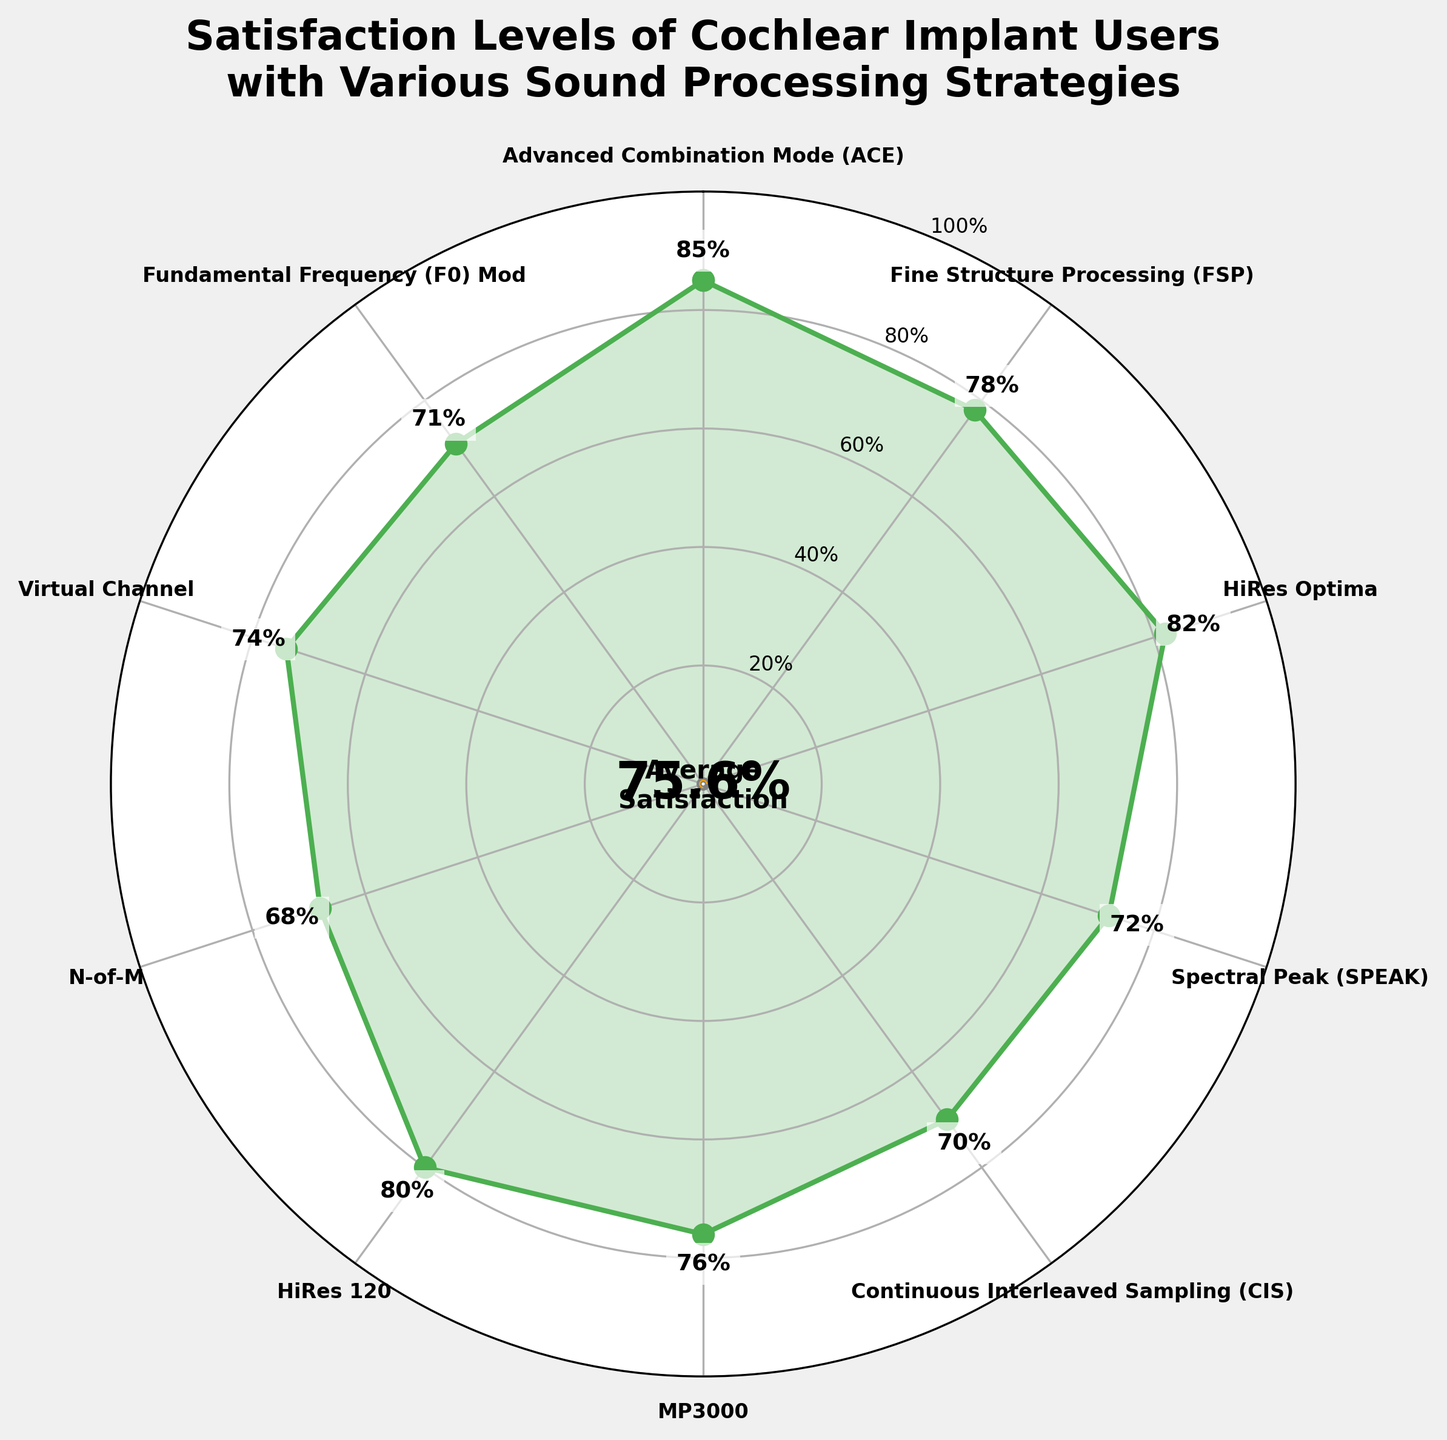What is the satisfaction level for the Continuous Interleaved Sampling (CIS) strategy? The satisfaction level for the Continuous Interleaved Sampling (CIS) strategy is directly labeled in the chart. It shows the value as 70%.
Answer: 70% Which sound processing strategy has the highest satisfaction level? To find the highest satisfaction level, look for the largest percentage value labeled among the strategies. The highest value is with the Advanced Combination Mode (ACE) at 85%.
Answer: Advanced Combination Mode (ACE) What is the average satisfaction level displayed in the middle of the gauge? The average satisfaction level is shown in the center of the gauge as a numerical percentage value. The chart displays it as 77.6%.
Answer: 77.6% How many sound processing strategies have a satisfaction level below 75%? Identify the strategies with satisfaction levels below the threshold of 75%. The strategies are Continuous Interleaved Sampling (CIS) at 70%, Spectral Peak (SPEAK) at 72%, and N-of-M at 68%, Virtual Channel at 74%, and Fundamental Frequency (F0) Mod at 71%. There are 5 such strategies.
Answer: 5 What is the angle position in the polar chart for the HiRes Optima strategy? Locate the HiRes Optima strategy label along the perimeter of the polar chart, which determines its angle. It is displayed at the angle value corresponding to its position in the sequence arranged clockwise. HiRes Optima is roughly at the 3 o'clock position, which corresponds to 90 degrees in a polar plot.
Answer: 90 degrees Which sound processing strategy has the lowest satisfaction level? Look for the smallest percentage in the chart. The lowest satisfaction level is associated with the N-of-M strategy at 68%.
Answer: N-of-M Is the satisfaction level for HiRes 120 higher or lower than that of MP3000? Compare the satisfaction levels for HiRes 120 and MP3000. HiRes 120 has a satisfaction level of 80%, and MP3000 has a satisfaction level of 76%. HiRes 120 is higher.
Answer: Higher What is the difference in satisfaction levels between Fine Structure Processing (FSP) and Spectral Peak (SPEAK)? Subtract the satisfaction level of Spectral Peak (SPEAK) from Fine Structure Processing (FSP). FSP is 78% and SPEAK is 72%, so the difference is 78% - 72% = 6%.
Answer: 6% What percentage of the gauge circle is filled by the average satisfaction level? The gauge displays an orange arc from 0 to the value of the average satisfaction. The average satisfaction is 77.6%, indicating 77.6% of the circle is filled.
Answer: 77.6% Which strategies have satisfaction levels between 70% and 80%? Identify the strategies with satisfaction levels in the range of 70% to 80%. These strategies are Fine Structure Processing (FSP) at 78%, Continuous Interleaved Sampling (CIS) at 70%, MP3000 at 76%, Virtual Channel at 74%, and Fundamental Frequency (F0) Mod at 71%. There are 5 such strategies.
Answer: Fine Structure Processing (FSP), Continuous Interleaved Sampling (CIS), MP3000, Virtual Channel, Fundamental Frequency (F0) Mod 